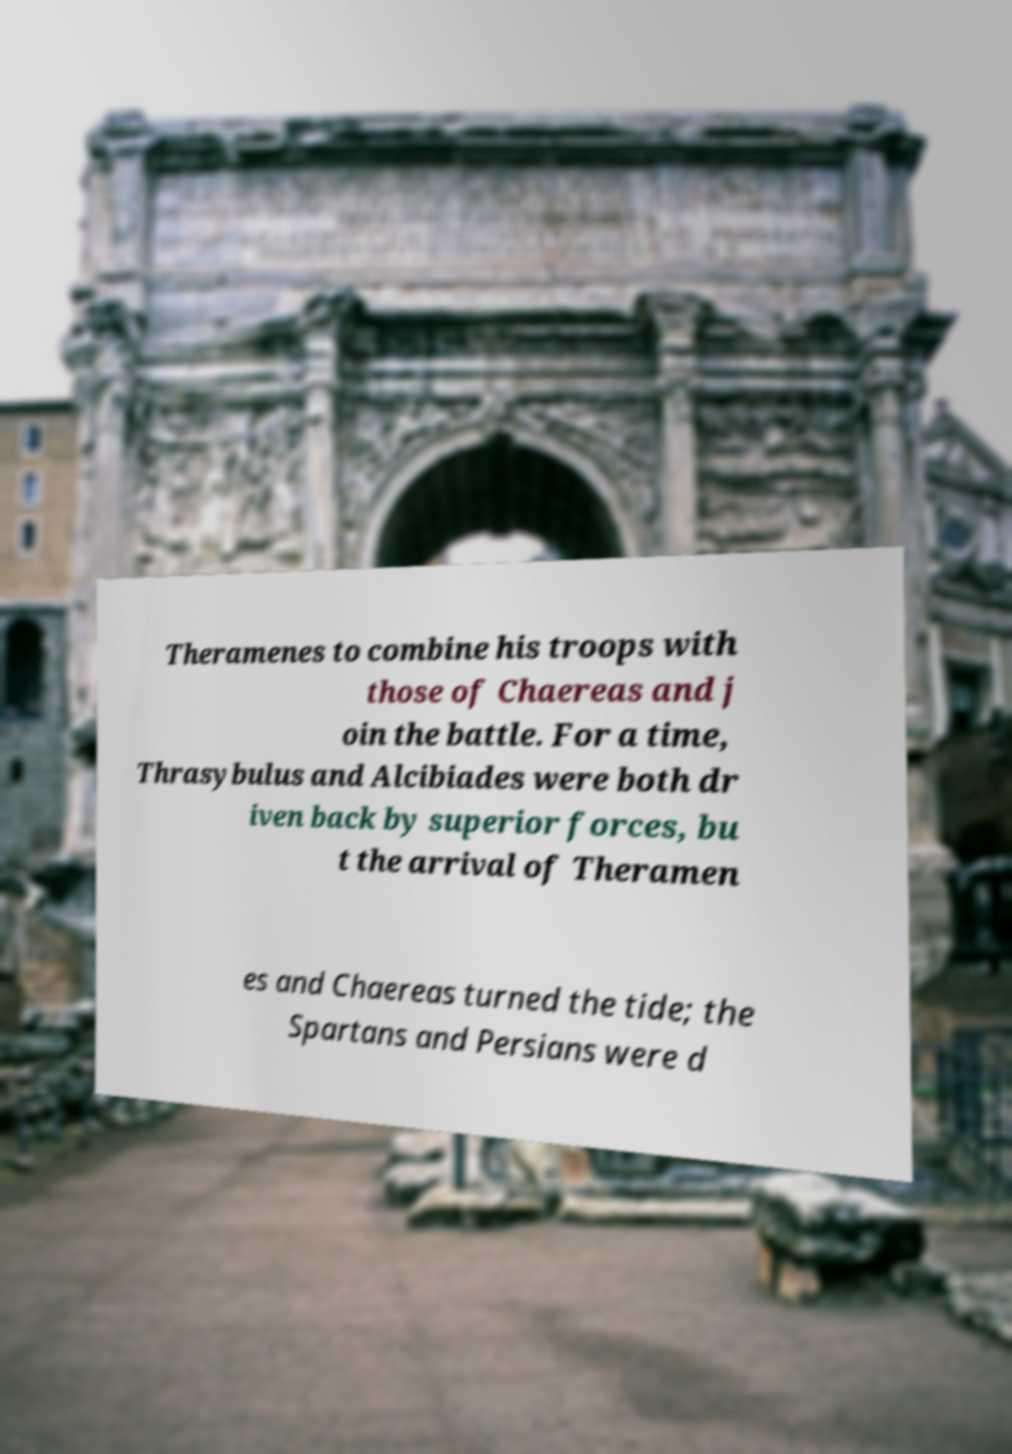Can you read and provide the text displayed in the image?This photo seems to have some interesting text. Can you extract and type it out for me? Theramenes to combine his troops with those of Chaereas and j oin the battle. For a time, Thrasybulus and Alcibiades were both dr iven back by superior forces, bu t the arrival of Theramen es and Chaereas turned the tide; the Spartans and Persians were d 